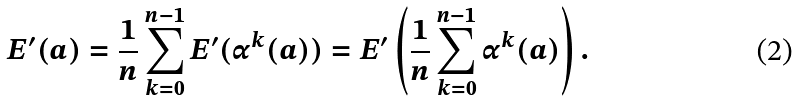<formula> <loc_0><loc_0><loc_500><loc_500>E ^ { \prime } ( a ) = \frac { 1 } { n } \sum _ { k = 0 } ^ { n - 1 } E ^ { \prime } ( \alpha ^ { k } ( a ) ) = E ^ { \prime } \left ( \frac { 1 } { n } \sum _ { k = 0 } ^ { n - 1 } \alpha ^ { k } ( a ) \right ) .</formula> 